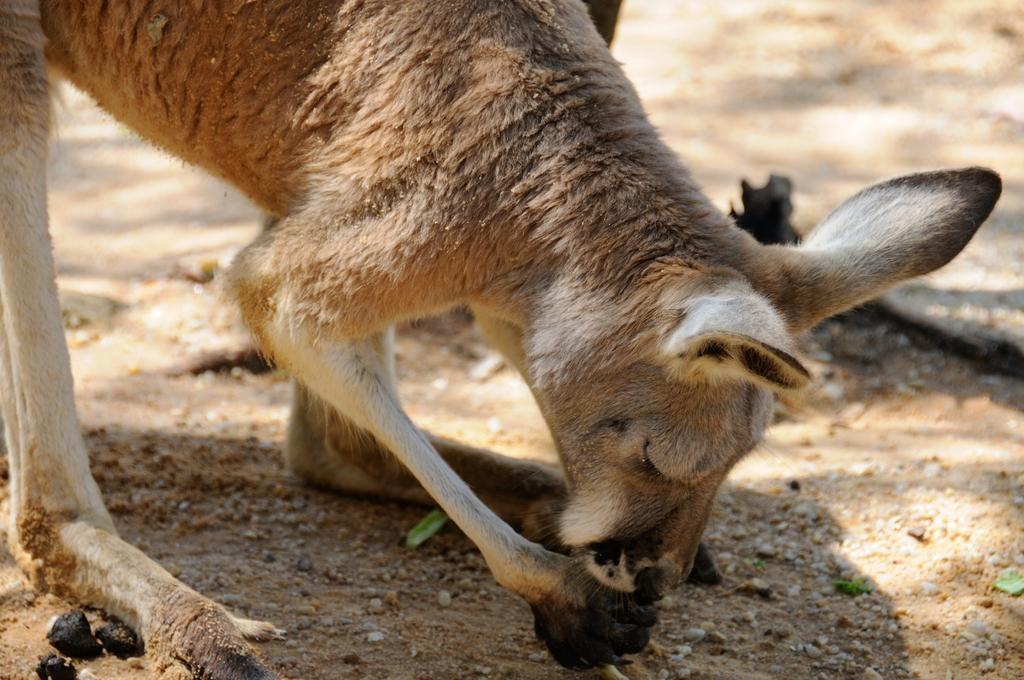Can you describe this image briefly? In the foreground of this image, there is a kangaroo standing and eating something. In the background, there is the land. 